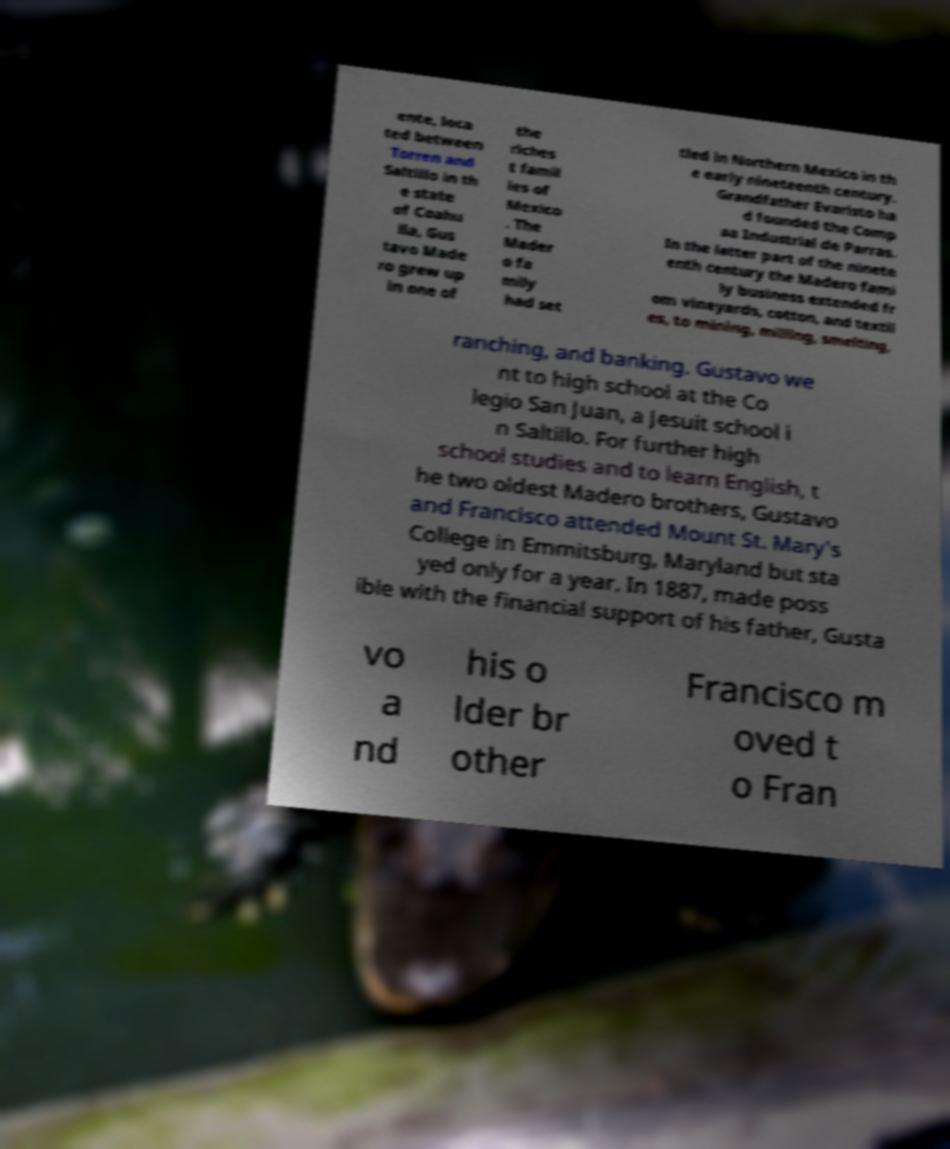Can you read and provide the text displayed in the image?This photo seems to have some interesting text. Can you extract and type it out for me? ente, loca ted between Torren and Saltillo in th e state of Coahu ila, Gus tavo Made ro grew up in one of the riches t famil ies of Mexico . The Mader o fa mily had set tled in Northern Mexico in th e early nineteenth century. Grandfather Evaristo ha d founded the Comp aa Industrial de Parras. In the latter part of the ninete enth century the Madero fami ly business extended fr om vineyards, cotton, and textil es, to mining, milling, smelting, ranching, and banking. Gustavo we nt to high school at the Co legio San Juan, a Jesuit school i n Saltillo. For further high school studies and to learn English, t he two oldest Madero brothers, Gustavo and Francisco attended Mount St. Mary's College in Emmitsburg, Maryland but sta yed only for a year. In 1887, made poss ible with the financial support of his father, Gusta vo a nd his o lder br other Francisco m oved t o Fran 